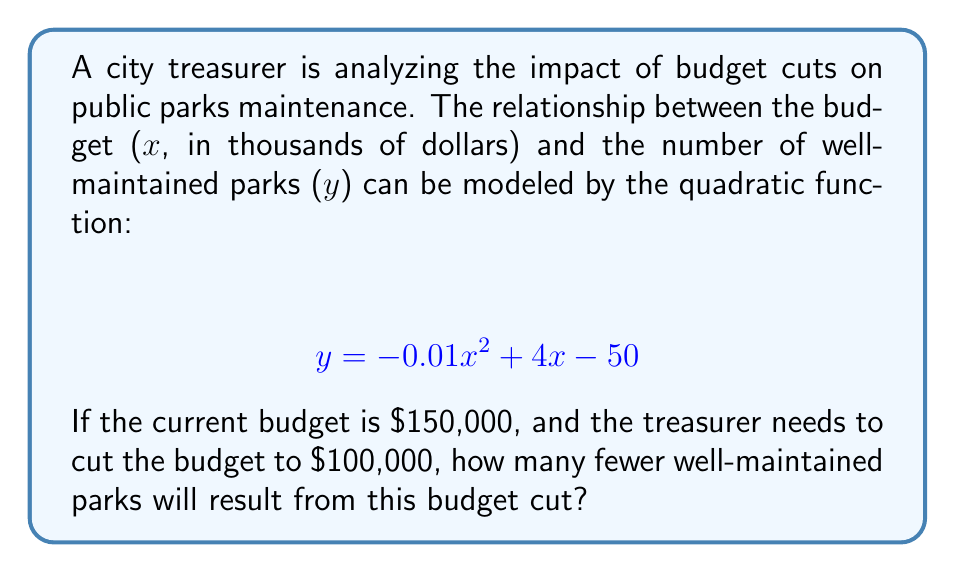Solve this math problem. To solve this problem, we need to:

1. Calculate the number of well-maintained parks at the current budget.
2. Calculate the number of well-maintained parks after the budget cut.
3. Find the difference between these two values.

Step 1: Calculate parks at current budget ($150,000)
Let $x = 150$ (since the budget is in thousands)
$$ y = -0.01(150)^2 + 4(150) - 50 $$
$$ y = -0.01(22500) + 600 - 50 $$
$$ y = -225 + 600 - 50 $$
$$ y = 325 \text{ parks} $$

Step 2: Calculate parks after budget cut ($100,000)
Let $x = 100$
$$ y = -0.01(100)^2 + 4(100) - 50 $$
$$ y = -0.01(10000) + 400 - 50 $$
$$ y = -100 + 400 - 50 $$
$$ y = 250 \text{ parks} $$

Step 3: Find the difference
$$ \text{Difference} = 325 - 250 = 75 \text{ parks} $$
Answer: 75 fewer well-maintained parks 